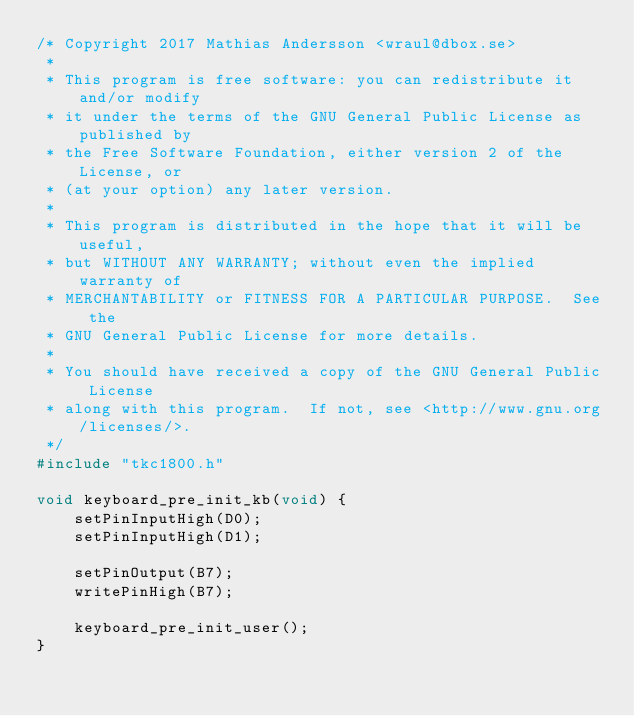<code> <loc_0><loc_0><loc_500><loc_500><_C_>/* Copyright 2017 Mathias Andersson <wraul@dbox.se>
 *
 * This program is free software: you can redistribute it and/or modify
 * it under the terms of the GNU General Public License as published by
 * the Free Software Foundation, either version 2 of the License, or
 * (at your option) any later version.
 *
 * This program is distributed in the hope that it will be useful,
 * but WITHOUT ANY WARRANTY; without even the implied warranty of
 * MERCHANTABILITY or FITNESS FOR A PARTICULAR PURPOSE.  See the
 * GNU General Public License for more details.
 *
 * You should have received a copy of the GNU General Public License
 * along with this program.  If not, see <http://www.gnu.org/licenses/>.
 */
#include "tkc1800.h"

void keyboard_pre_init_kb(void) {
    setPinInputHigh(D0);
    setPinInputHigh(D1);

    setPinOutput(B7);
    writePinHigh(B7);

    keyboard_pre_init_user();
}
</code> 